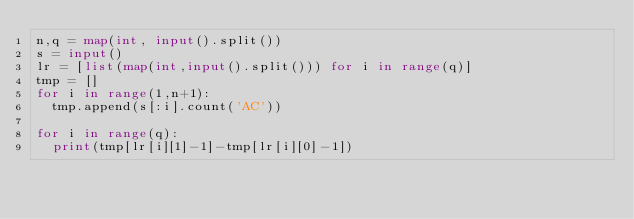<code> <loc_0><loc_0><loc_500><loc_500><_Python_>n,q = map(int, input().split())
s = input()
lr = [list(map(int,input().split())) for i in range(q)]
tmp = []
for i in range(1,n+1):
  tmp.append(s[:i].count('AC'))

for i in range(q):
  print(tmp[lr[i][1]-1]-tmp[lr[i][0]-1])</code> 